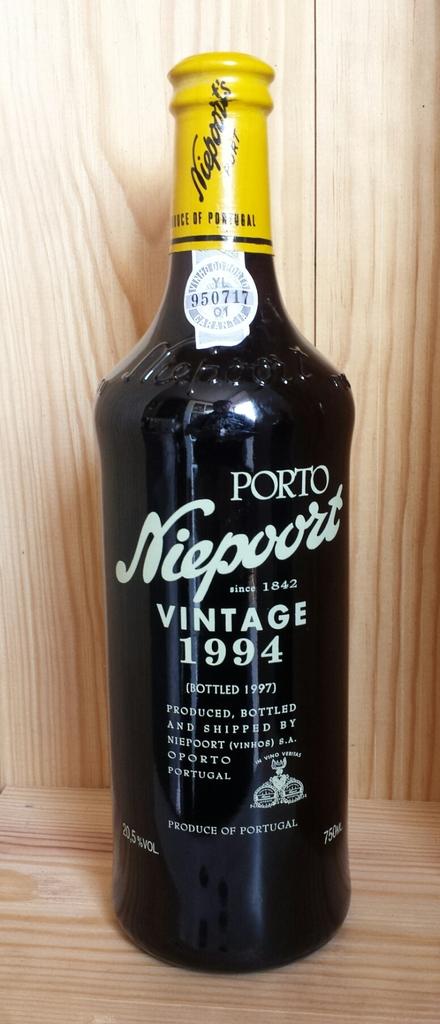What vintage year is this beverage?
Your answer should be very brief. 1994. What year was this drink bottled?
Your response must be concise. 1994. 